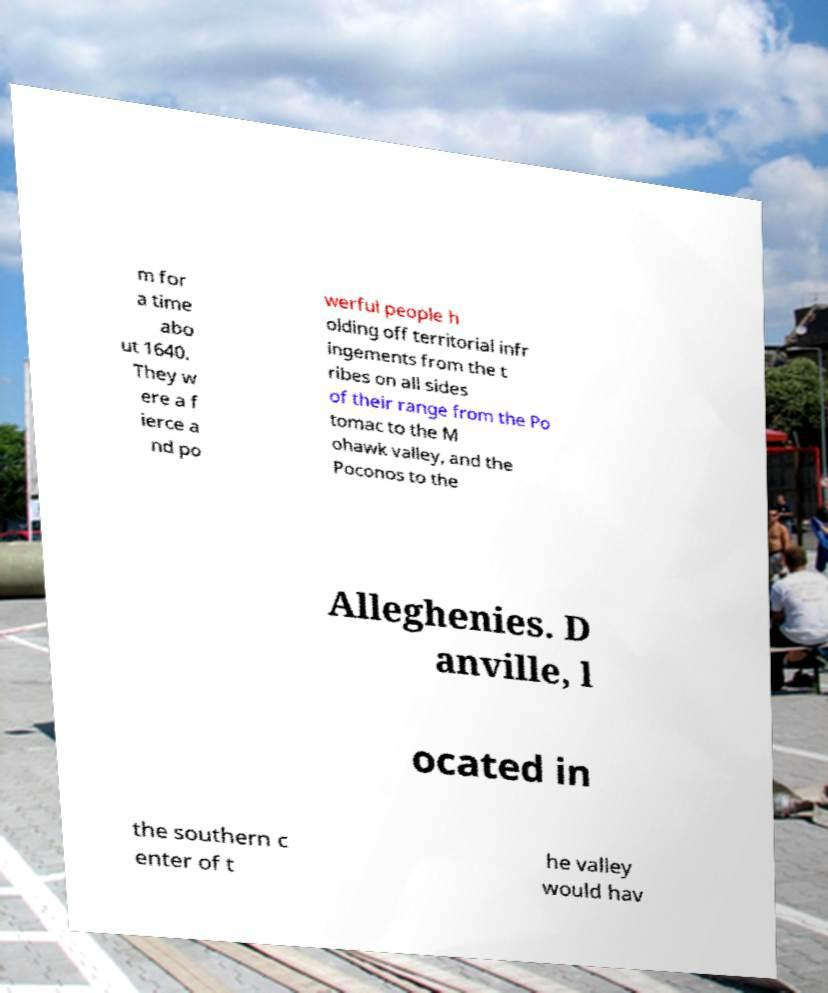Can you read and provide the text displayed in the image?This photo seems to have some interesting text. Can you extract and type it out for me? m for a time abo ut 1640. They w ere a f ierce a nd po werful people h olding off territorial infr ingements from the t ribes on all sides of their range from the Po tomac to the M ohawk valley, and the Poconos to the Alleghenies. D anville, l ocated in the southern c enter of t he valley would hav 